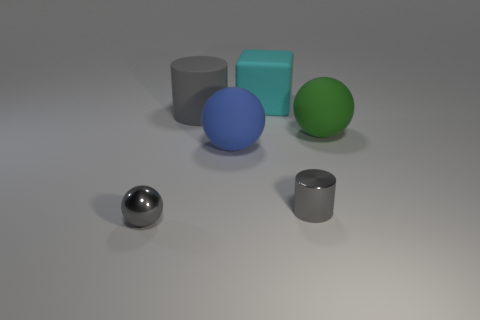The large sphere that is right of the small gray metallic object on the right side of the metallic sphere is made of what material?
Provide a succinct answer. Rubber. What is the material of the sphere that is behind the big blue matte object?
Your answer should be very brief. Rubber. Do the tiny metallic ball and the tiny shiny cylinder have the same color?
Ensure brevity in your answer.  Yes. There is a tiny gray object that is behind the small gray shiny object on the left side of the cylinder that is behind the big blue matte sphere; what is its material?
Ensure brevity in your answer.  Metal. There is a big blue sphere; are there any gray rubber objects in front of it?
Make the answer very short. No. What shape is the blue matte object that is the same size as the cyan rubber thing?
Provide a short and direct response. Sphere. Is the tiny cylinder made of the same material as the blue sphere?
Your answer should be compact. No. How many matte things are either small objects or green things?
Provide a succinct answer. 1. What is the shape of the big object that is the same color as the metal cylinder?
Ensure brevity in your answer.  Cylinder. Does the tiny object left of the small cylinder have the same color as the big rubber cylinder?
Ensure brevity in your answer.  Yes. 